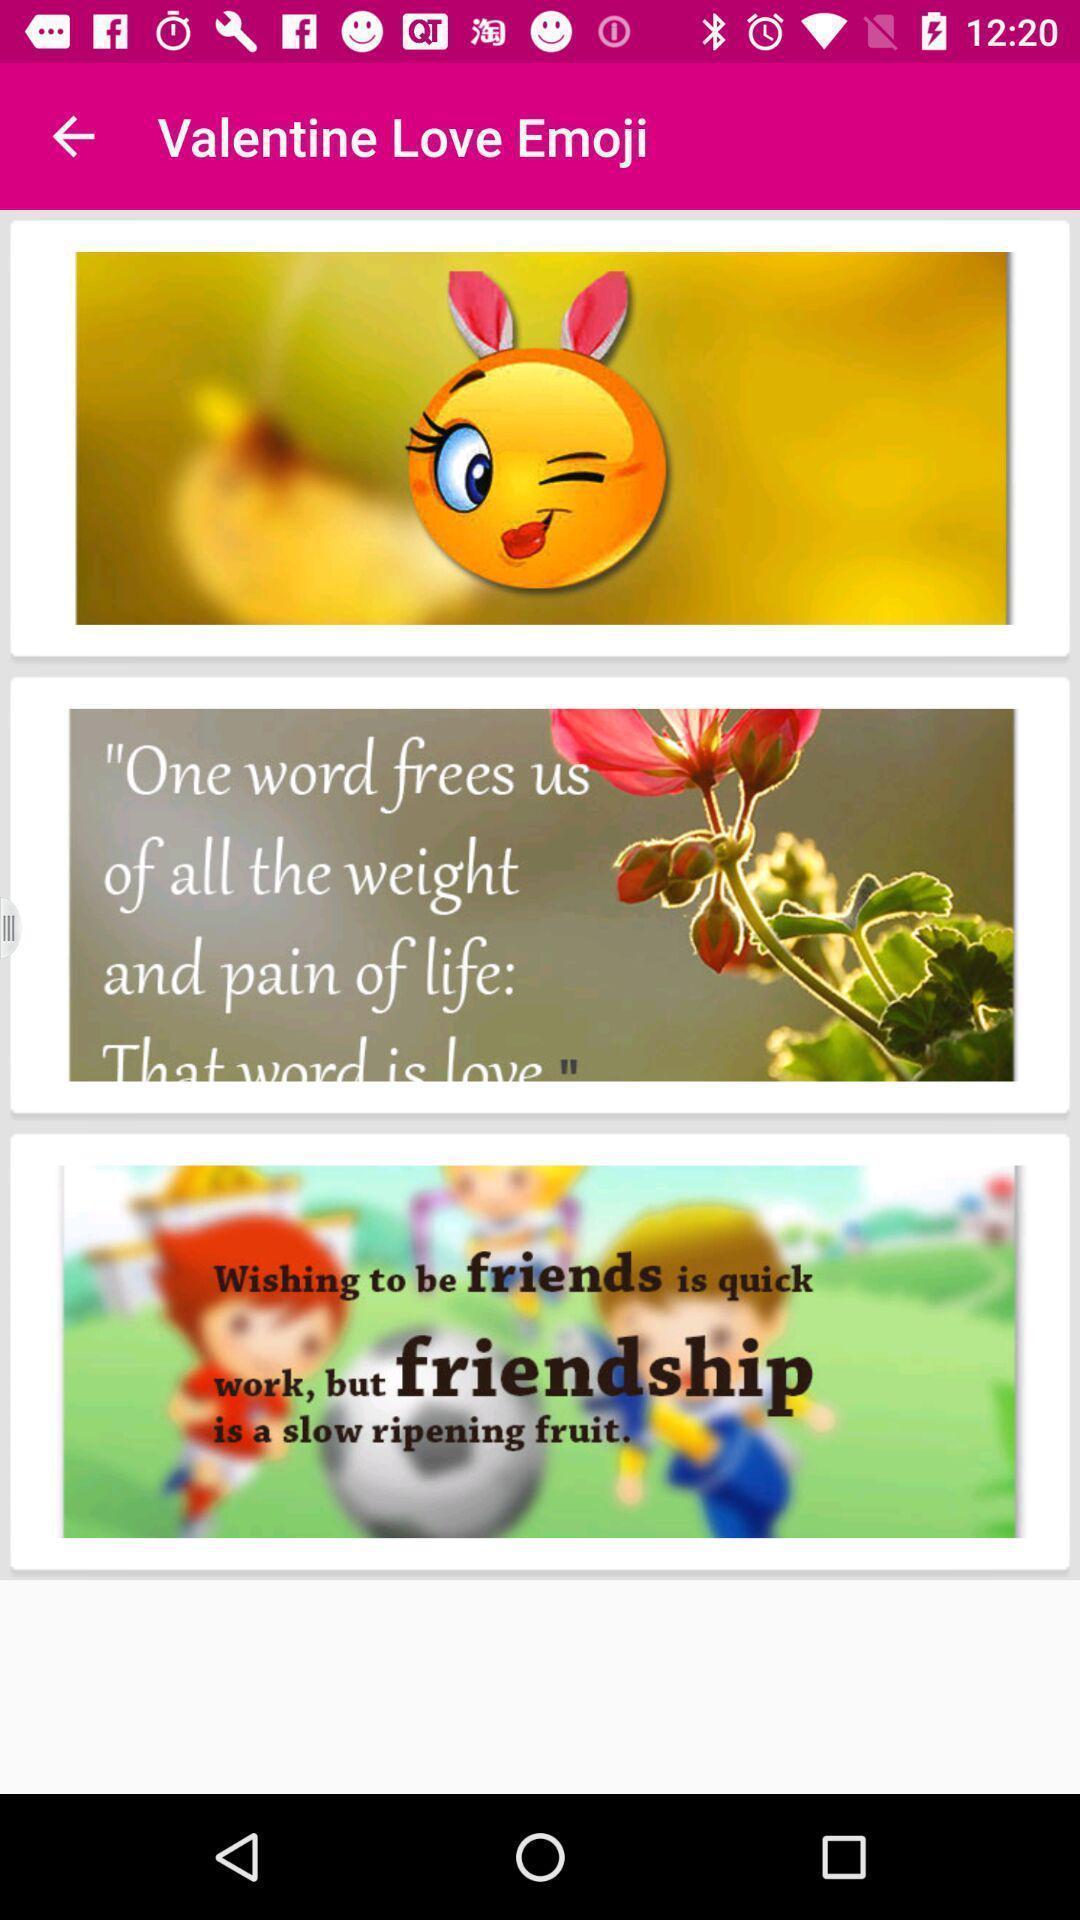Describe the key features of this screenshot. Screen showing love emoji on a mobile application. 